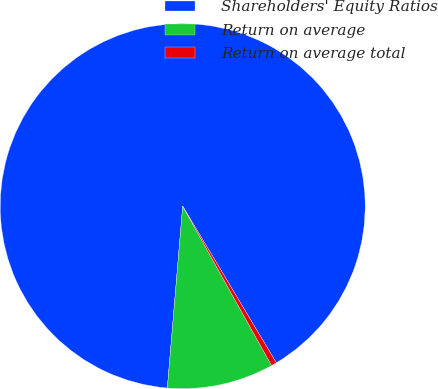<chart> <loc_0><loc_0><loc_500><loc_500><pie_chart><fcel>Shareholders' Equity Ratios<fcel>Return on average<fcel>Return on average total<nl><fcel>90.09%<fcel>9.44%<fcel>0.48%<nl></chart> 